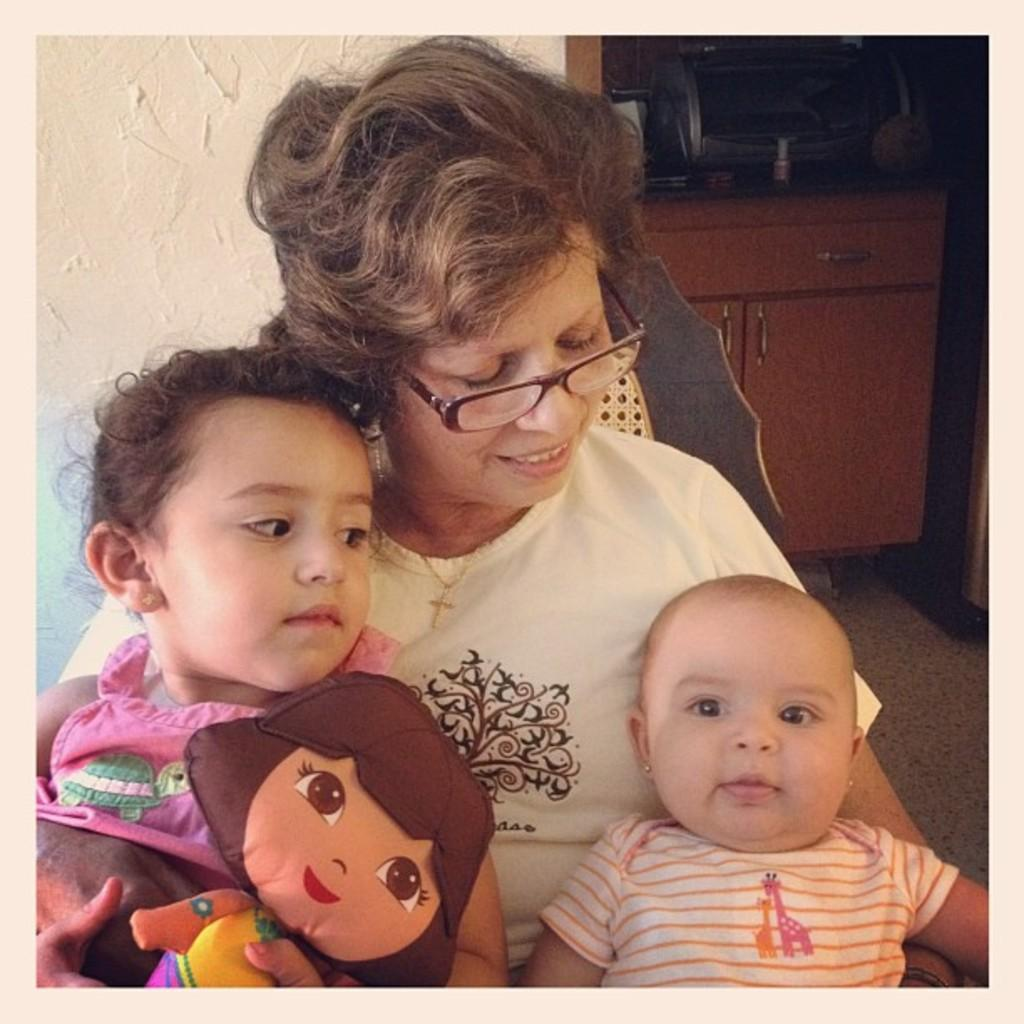Who is present in the image? There are women and children in the image. What are they doing in the image? They are sitting on chairs. What can be seen in the background of the image? There is a wall and cupboards in the background of the image. What team do the women and children belong to in the image? There is no indication of a team or any affiliation in the image. 